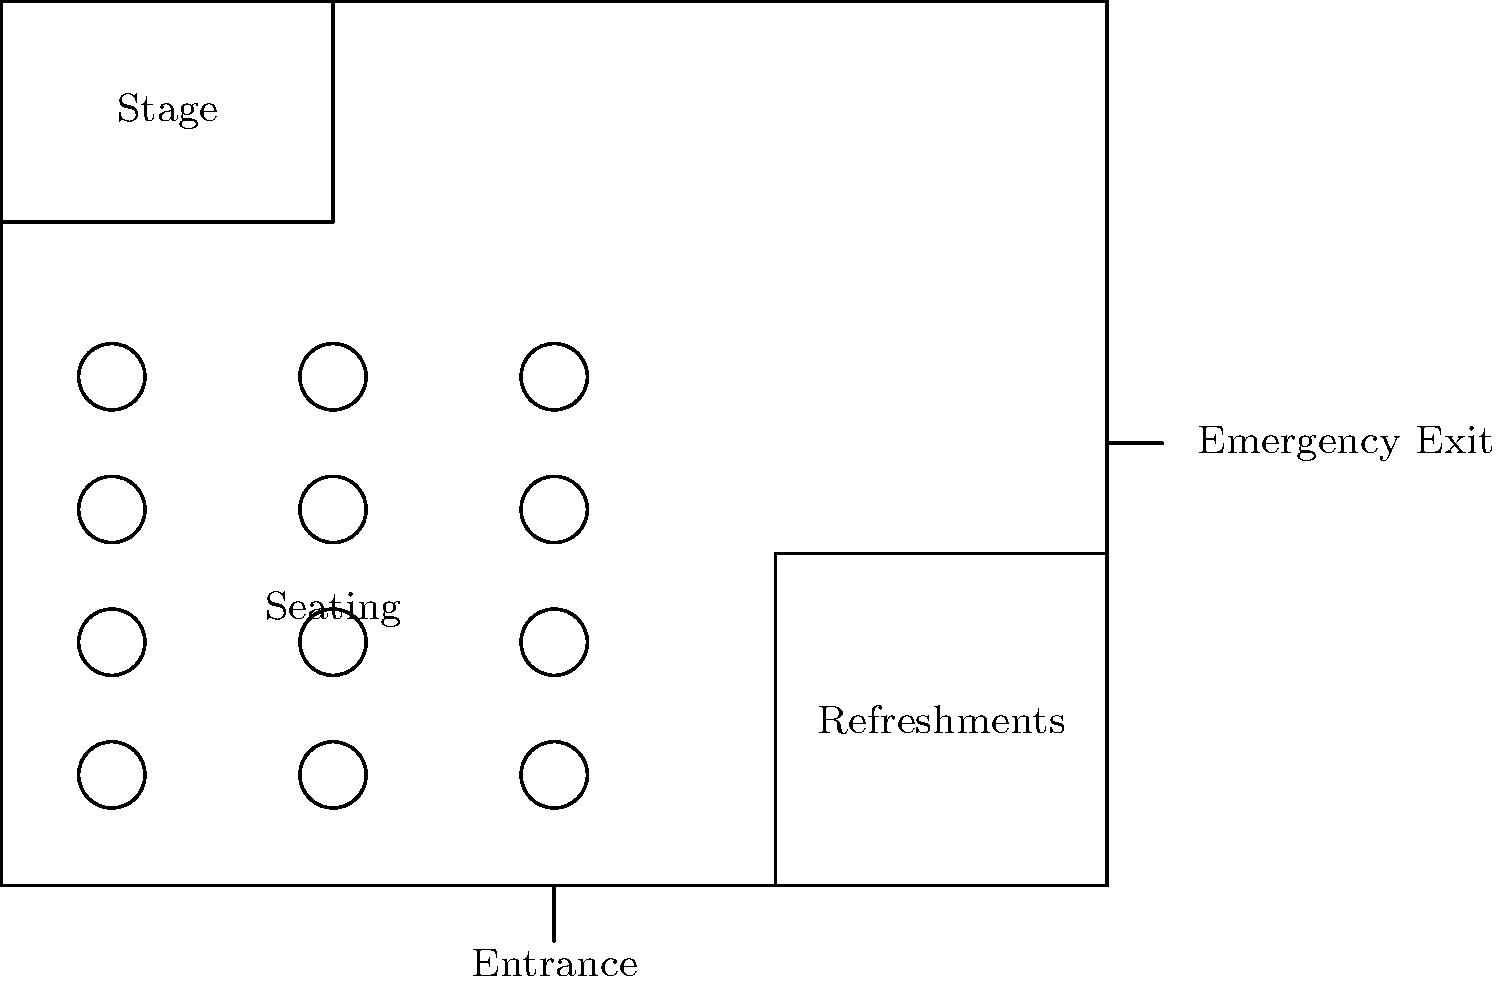As the organizer of a community event in Lancaster County, you're reviewing the floor plan for a proposed event space. The diagram shows a rectangular space with designated areas for a stage, seating, and refreshments. Given the layout, what is the most efficient way to ensure smooth foot traffic flow and easy access to all areas, especially considering the locations of the main entrance and emergency exit? To ensure smooth foot traffic flow and easy access to all areas, we need to consider the following points:

1. Main Entrance: Located at the bottom center of the space, providing direct access to the seating area.

2. Seating Area: Positioned in the center-left of the space, allowing for clear sightlines to the stage.

3. Stage: Located at the top-left corner, visible from the seating area.

4. Refreshment Area: Situated in the bottom-right corner, easily accessible from both the entrance and seating area.

5. Emergency Exit: Located on the right side, near the top.

The most efficient way to ensure smooth foot traffic flow and easy access would be:

1. Keep the central area between the seating and refreshment areas clear for movement.
2. Create a wide aisle from the entrance to the back of the seating area.
3. Ensure there's a clear path from the seating area to the refreshment area.
4. Maintain a clear route from all areas to the emergency exit.
5. Consider placing directional signs to guide attendees to different areas.

This layout allows for easy movement between all areas while maintaining safety and accessibility. The central positioning of the entrance provides a natural flow to all areas, and the emergency exit is readily accessible from any point in the space.
Answer: Create wide, clear pathways between entrance, seating, refreshments, and emergency exit. 